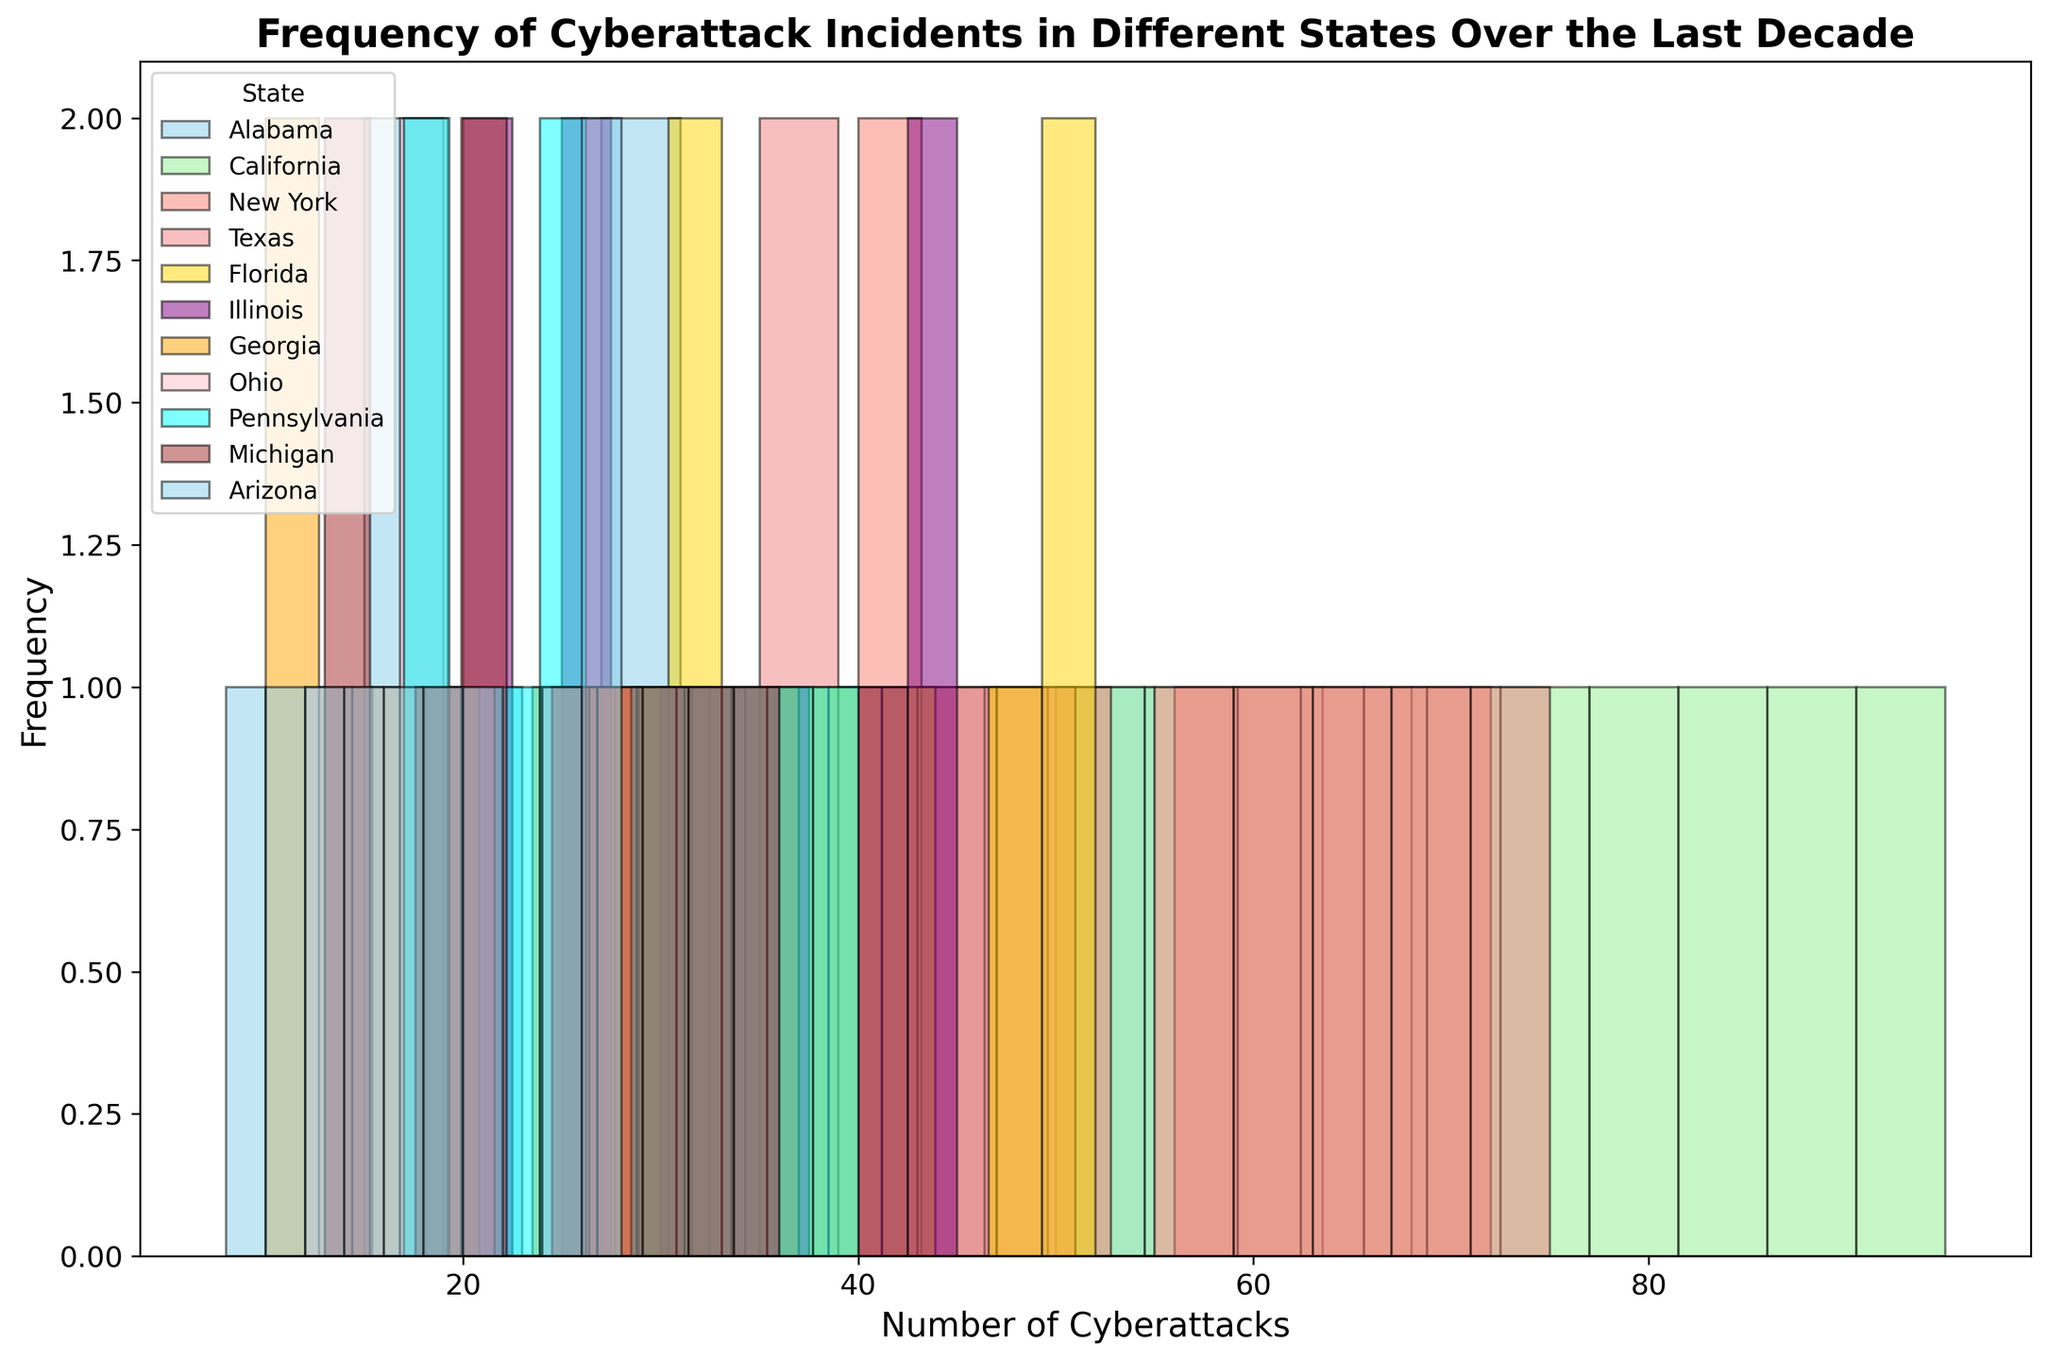Which state has the highest frequency of cyberattacks over the last decade? The histogram shows each state's number of cyberattacks over the last decade with varying bar heights representing frequencies. California has the highest frequency as its bars appear the tallest and most consistent in height.
Answer: California How does the frequency of cyberattacks in New York compare to Texas? The histogram shows the frequency of cyberattacks with different colored bars for each state. New York's bars are generally higher than Texas's bars indicating a higher frequency of cyberattacks across the years.
Answer: New York has a higher frequency than Texas Which state has the least frequency of cyberattacks in 2022? The histogram shows the number of cyberattacks per state. The bar corresponding to Georgia is among the shortest heights, indicating the least frequency of cyberattacks in 2022 compared to other states like California or New York.
Answer: Georgia What is the approximate average number of cyberattacks in Illinois over the last decade? To find the average, we would add up the number of cyberattacks for Illinois from 2013 to 2022 and divide by 10. Summing up 20, 22, 25, 27, 30, 33, 36, 40, 43, and 45 gives 321. Dividing 321 by 10 gives 32.1.
Answer: 32.1 Compare the growth in the number of cyberattacks between Florida and Ohio over the last decade. Looking at the histogram, both states have an upward trend in the number of cyberattacks over the years. Florida started with lower values but ends up higher, while Ohio starts and ends higher but grows slower. Florida's growth rate appears steeper.
Answer: Florida has a steeper growth rate than Ohio How do the frequencies of cyberattacks in Pennsylvania and Michigan compare in 2019? The histogram shows different states with varying bar heights for each year. In 2019, Pennsylvania's bar is higher than Michigan's, indicating a higher frequency of cyberattacks in Pennsylvania.
Answer: Pennsylvania has a higher frequency than Michigan If we compare Georgia and Arizona, which state had the highest increase in cyberattack frequency from 2013 to 2022? Georgia started at 10 in 2013 and went to 37 in 2022 (an increase of 27). Arizona started at 8 in 2013 and ended at 28 in 2022 (an increase of 20). The histogram confirms this difference.
Answer: Georgia had a higher increase Which two states show the most similar pattern in the frequency of cyberattacks over the last decade? By comparing the histograms of all states, Illinois and Pennsylvania have bars with similar heights and growth trends over the last decade, indicating similar patterns in the number of cyberattacks.
Answer: Illinois and Pennsylvania What is the median number of cyberattacks for Texas in the given period? To find the median, we list Texas's values: 35, 38, 42, 45, 50, 55, 60, 65, 70, and 75. The median is the average of the 5th and 6th values (50 and 55), which gives: (50+55)/2 = 52.5.
Answer: 52.5 What is the total frequency of cyberattacks in Arizona and Ohio combined for 2017? The histogram shows Arizona with 16 and Ohio with 21 in 2017. Adding them together gives 16 + 21 = 37.
Answer: 37 